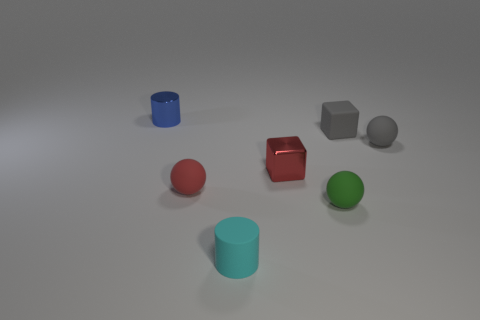Add 1 small metal things. How many objects exist? 8 Subtract all blocks. How many objects are left? 5 Subtract all tiny green rubber balls. Subtract all metal things. How many objects are left? 4 Add 6 gray matte objects. How many gray matte objects are left? 8 Add 3 red metallic things. How many red metallic things exist? 4 Subtract 0 brown cubes. How many objects are left? 7 